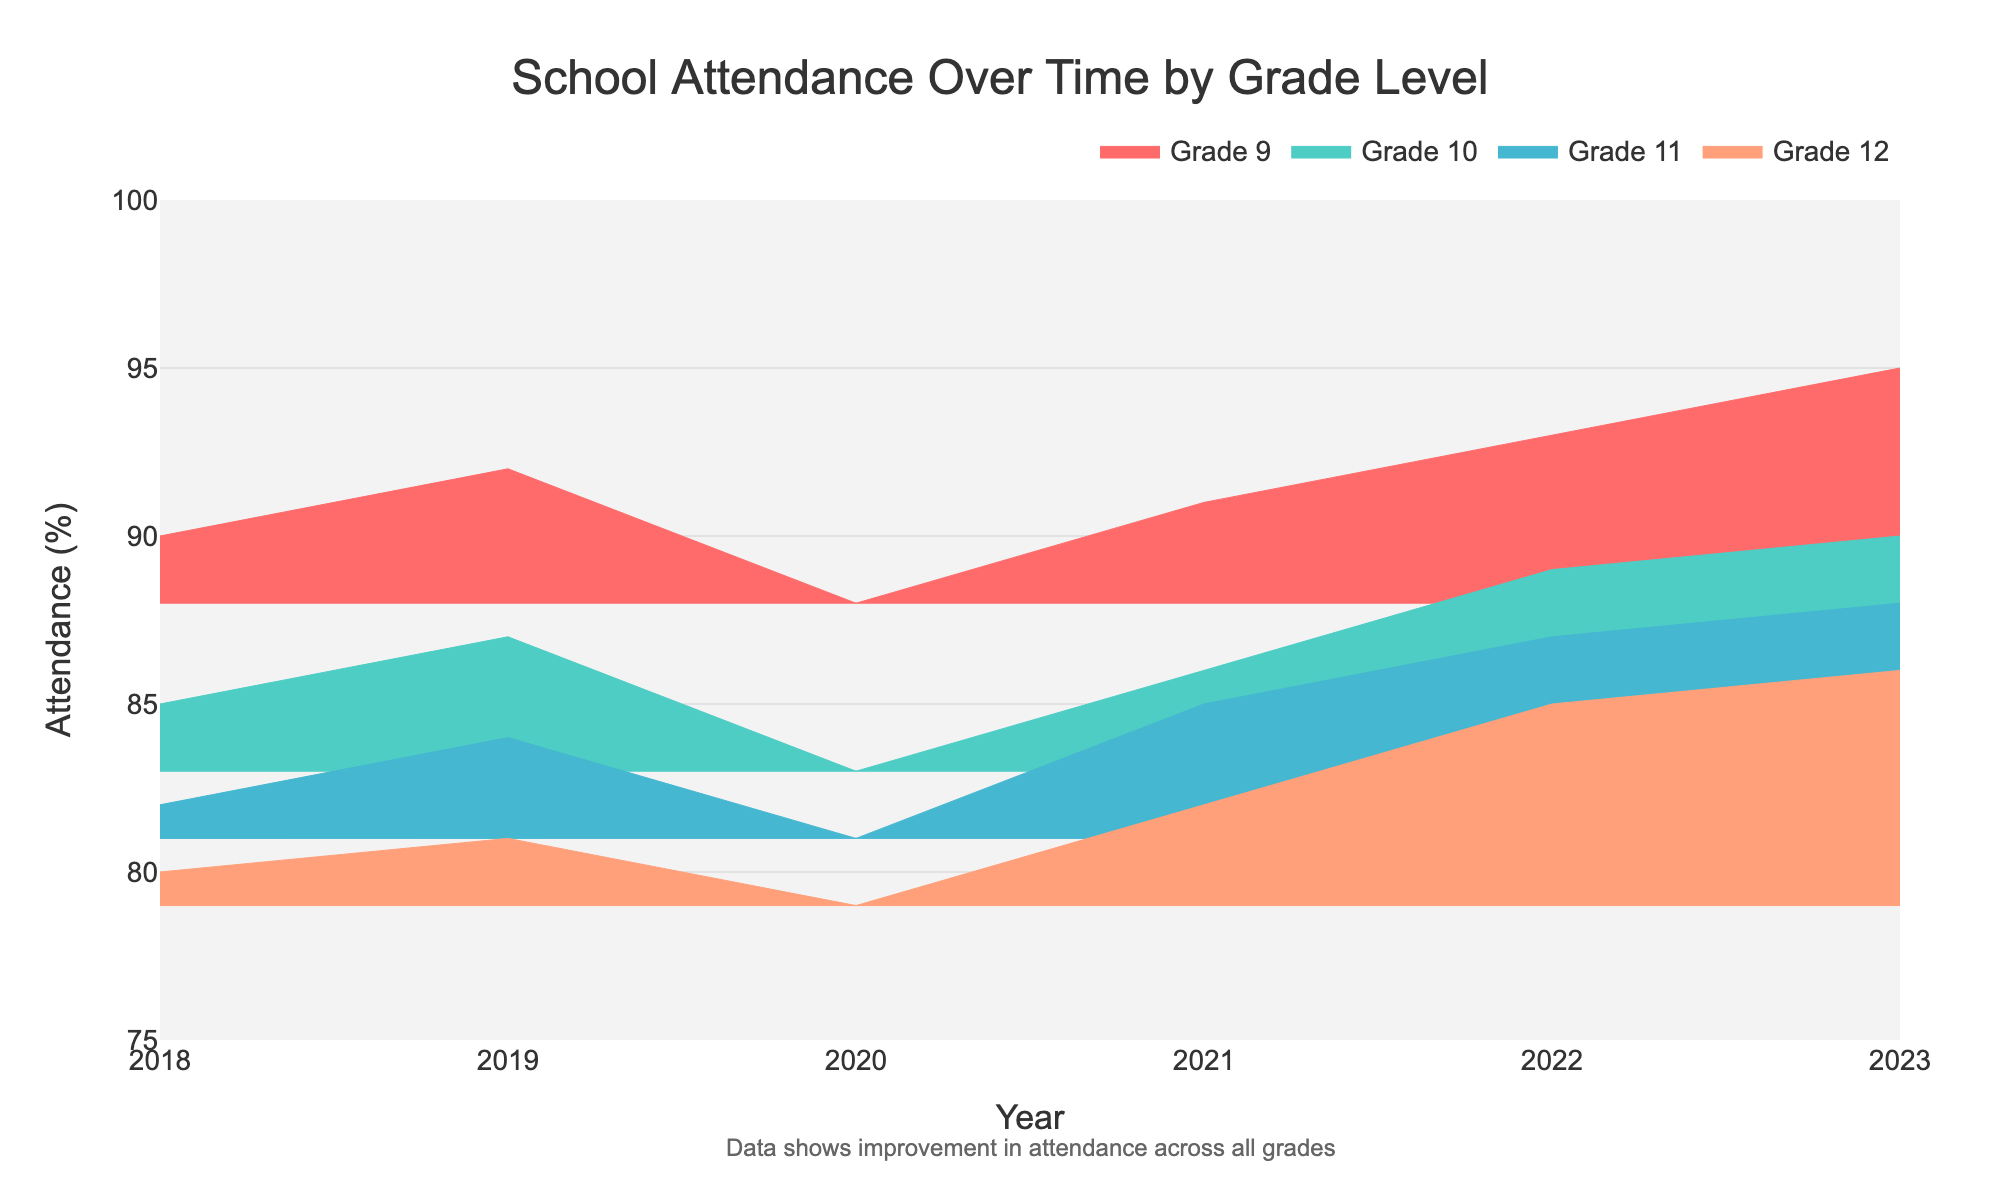What is the title of the chart? The title of the chart is usually positioned at the top and provides a summary of what the chart represents. In this case, the title is displayed clearly across the top area of the figure.
Answer: School Attendance Over Time by Grade Level Which grade had the lowest school attendance in 2020? Look at the step areas corresponding to each grade and check the y-values for the year 2020. Identify which grade has the lowest value among them.
Answer: Grade 12 What was the attendance percentage for Grade 9 in 2018? Locate the step area for Grade 9 and trace it to the year 2018 on the x-axis. Check the corresponding y-value to find the attendance percentage.
Answer: 90% In what year did Grade 11 first reach an attendance percentage of 85%? Examine the step area corresponding to Grade 11, and find the year where the y-value first hits 85%.
Answer: 2021 What pattern do you notice in school attendance trends over the given years? Observe the overall shape and movement of the step areas for each grade. Note if they are increasing, decreasing, or fluctuating.
Answer: Overall, attendance is increasing across all grades 